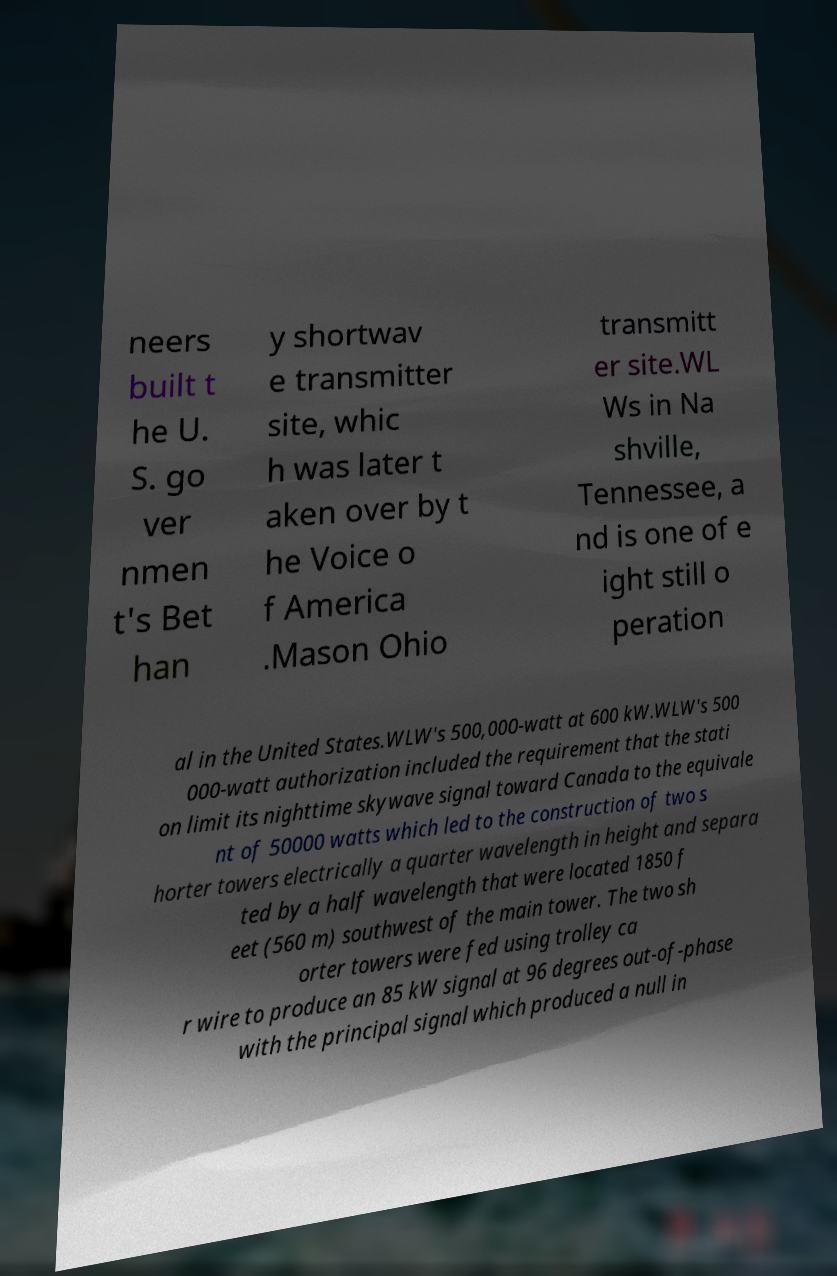There's text embedded in this image that I need extracted. Can you transcribe it verbatim? neers built t he U. S. go ver nmen t's Bet han y shortwav e transmitter site, whic h was later t aken over by t he Voice o f America .Mason Ohio transmitt er site.WL Ws in Na shville, Tennessee, a nd is one of e ight still o peration al in the United States.WLW's 500,000-watt at 600 kW.WLW's 500 000-watt authorization included the requirement that the stati on limit its nighttime skywave signal toward Canada to the equivale nt of 50000 watts which led to the construction of two s horter towers electrically a quarter wavelength in height and separa ted by a half wavelength that were located 1850 f eet (560 m) southwest of the main tower. The two sh orter towers were fed using trolley ca r wire to produce an 85 kW signal at 96 degrees out-of-phase with the principal signal which produced a null in 